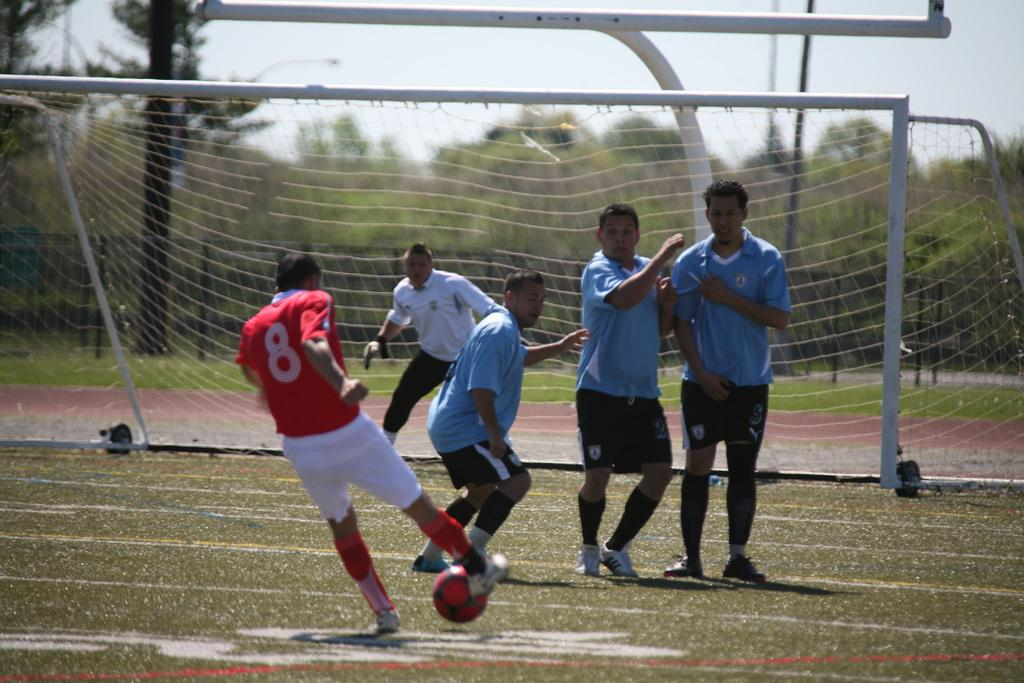What are the persons in the image doing? The persons in the image are playing in the ground. What object can be seen in the image that they might be using for their game? There is a ball in the image. What type of barrier is present in the image? There is a mesh in the image. What can be seen in the background of the image? Trees and the sky are visible in the background of the image. What type of trousers are the committee members wearing in the image? There is no committee or committee members present in the image, and therefore no trousers can be observed. Is the ground covered in snow in the image? There is no snow present in the image; the persons are playing on a ground with trees and the sky visible in the background. 